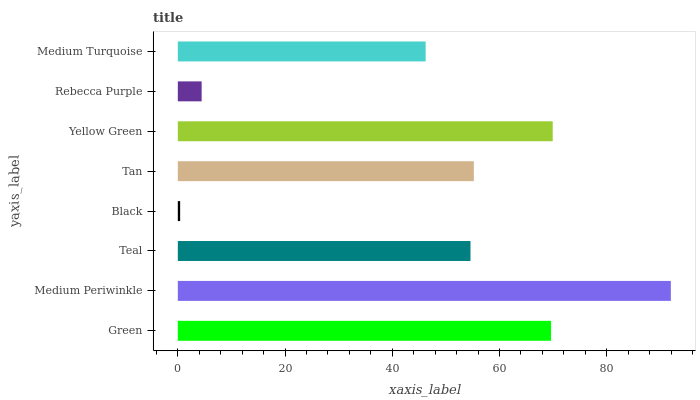Is Black the minimum?
Answer yes or no. Yes. Is Medium Periwinkle the maximum?
Answer yes or no. Yes. Is Teal the minimum?
Answer yes or no. No. Is Teal the maximum?
Answer yes or no. No. Is Medium Periwinkle greater than Teal?
Answer yes or no. Yes. Is Teal less than Medium Periwinkle?
Answer yes or no. Yes. Is Teal greater than Medium Periwinkle?
Answer yes or no. No. Is Medium Periwinkle less than Teal?
Answer yes or no. No. Is Tan the high median?
Answer yes or no. Yes. Is Teal the low median?
Answer yes or no. Yes. Is Rebecca Purple the high median?
Answer yes or no. No. Is Yellow Green the low median?
Answer yes or no. No. 